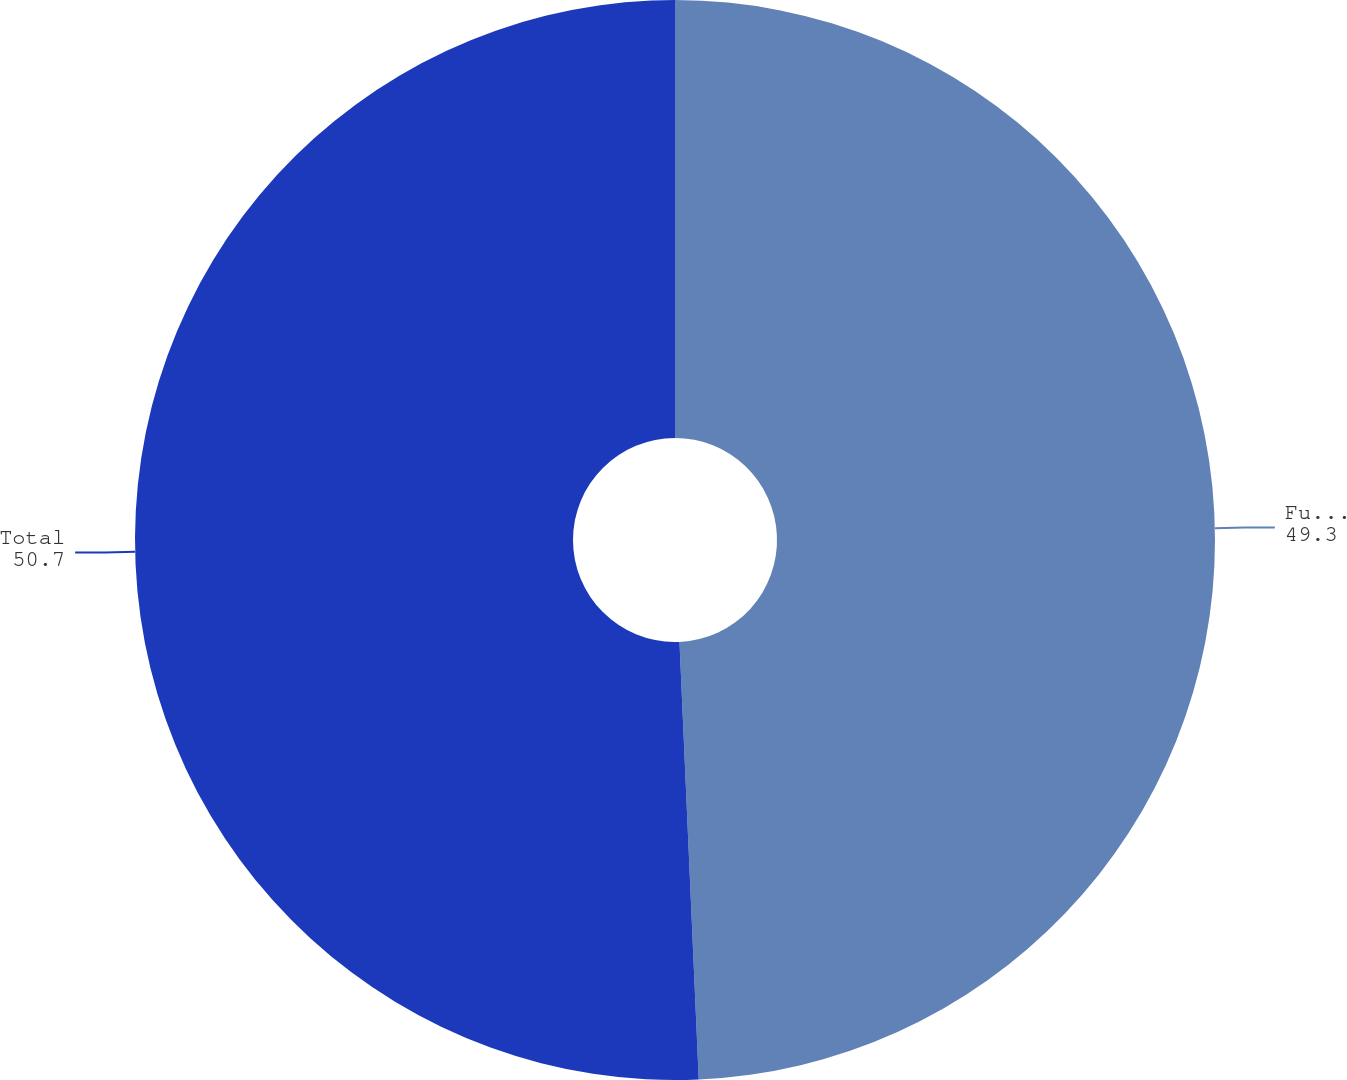Convert chart to OTSL. <chart><loc_0><loc_0><loc_500><loc_500><pie_chart><fcel>Future policy benefits<fcel>Total<nl><fcel>49.3%<fcel>50.7%<nl></chart> 